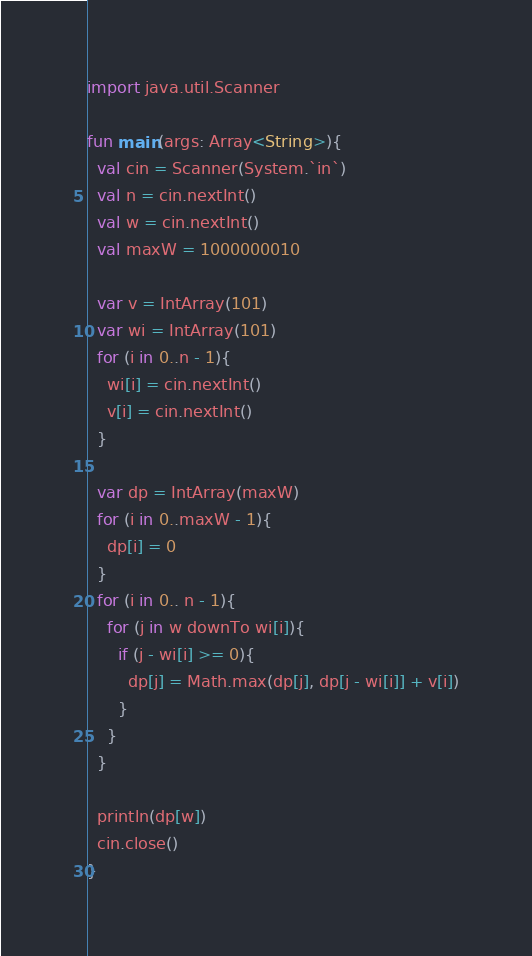Convert code to text. <code><loc_0><loc_0><loc_500><loc_500><_Kotlin_>import java.util.Scanner

fun main(args: Array<String>){
  val cin = Scanner(System.`in`)
  val n = cin.nextInt()
  val w = cin.nextInt()
  val maxW = 1000000010

  var v = IntArray(101)
  var wi = IntArray(101)
  for (i in 0..n - 1){
    wi[i] = cin.nextInt()
    v[i] = cin.nextInt()
  }

  var dp = IntArray(maxW)
  for (i in 0..maxW - 1){
    dp[i] = 0
  }
  for (i in 0.. n - 1){
    for (j in w downTo wi[i]){
      if (j - wi[i] >= 0){
        dp[j] = Math.max(dp[j], dp[j - wi[i]] + v[i])
      }
    }
  }
  
  println(dp[w])
  cin.close()
}</code> 